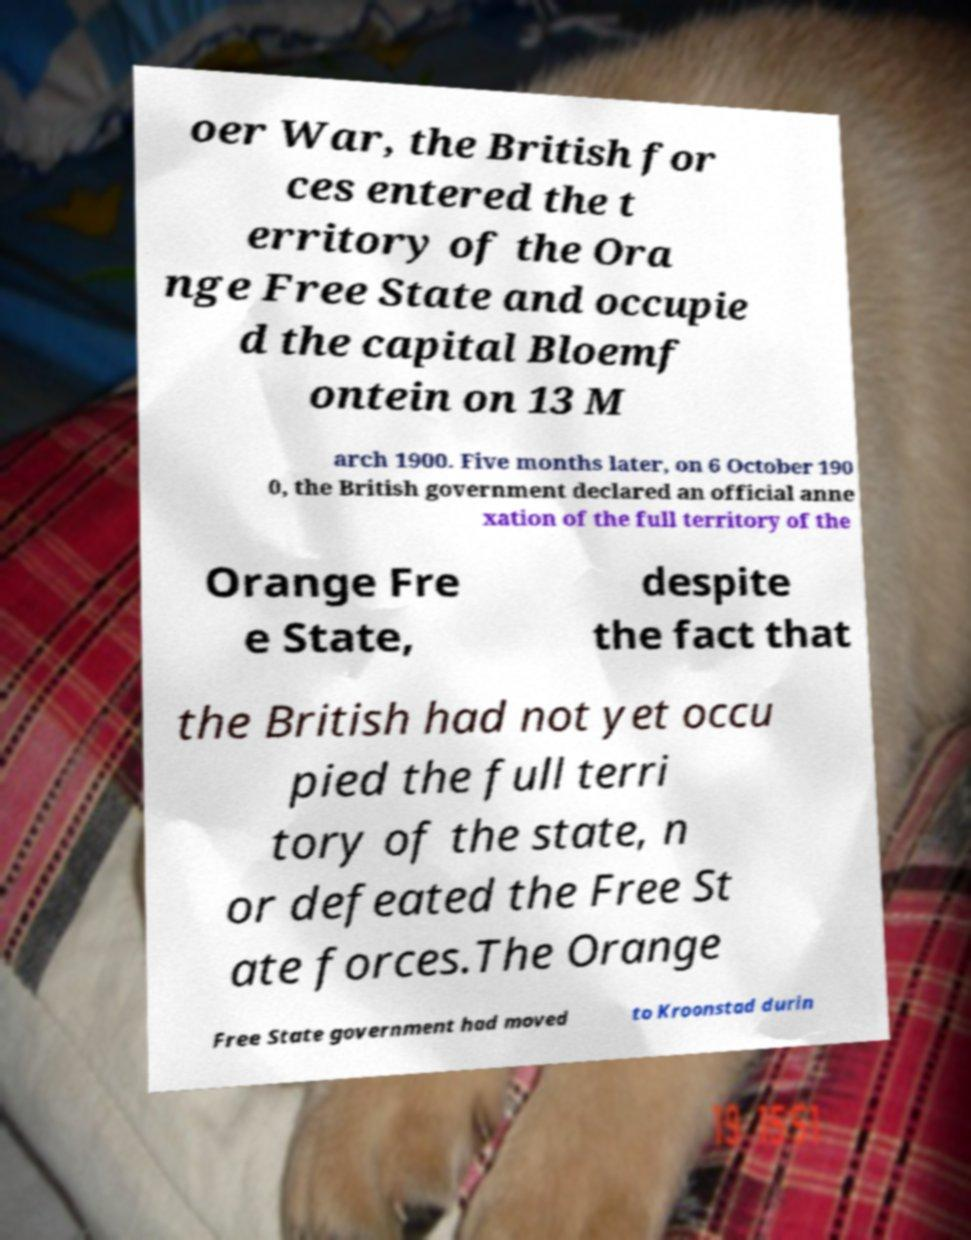Can you accurately transcribe the text from the provided image for me? oer War, the British for ces entered the t erritory of the Ora nge Free State and occupie d the capital Bloemf ontein on 13 M arch 1900. Five months later, on 6 October 190 0, the British government declared an official anne xation of the full territory of the Orange Fre e State, despite the fact that the British had not yet occu pied the full terri tory of the state, n or defeated the Free St ate forces.The Orange Free State government had moved to Kroonstad durin 